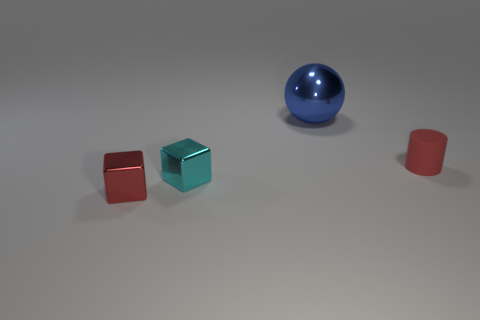Is there any other thing that has the same shape as the blue metallic thing?
Provide a succinct answer. No. Do the red thing to the right of the blue ball and the blue ball have the same size?
Your answer should be compact. No. The other thing that is the same shape as the small cyan object is what size?
Give a very brief answer. Small. There is a cylinder that is the same size as the red block; what material is it?
Make the answer very short. Rubber. There is another object that is the same shape as the small red metal thing; what is it made of?
Give a very brief answer. Metal. How many other things are there of the same size as the cyan metal block?
Give a very brief answer. 2. What is the size of the thing that is the same color as the tiny rubber cylinder?
Make the answer very short. Small. What number of small metal blocks are the same color as the cylinder?
Offer a terse response. 1. The blue metal object is what shape?
Ensure brevity in your answer.  Sphere. What color is the metallic object that is behind the red block and in front of the sphere?
Offer a very short reply. Cyan. 